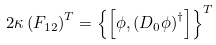Convert formula to latex. <formula><loc_0><loc_0><loc_500><loc_500>2 \kappa \left ( F _ { 1 2 } \right ) ^ { T } = \left \{ \left [ \phi , \left ( D _ { 0 } \phi \right ) ^ { \dagger } \right ] \right \} ^ { T }</formula> 